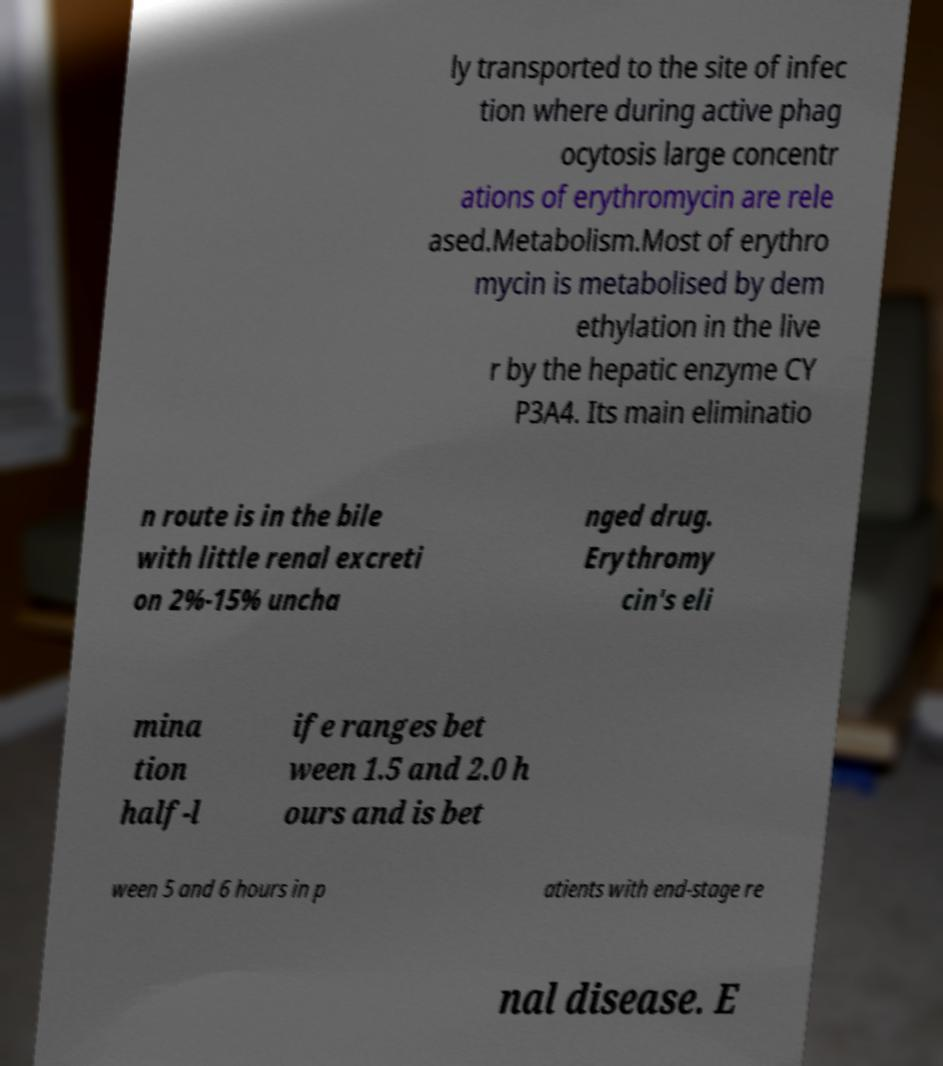Please identify and transcribe the text found in this image. ly transported to the site of infec tion where during active phag ocytosis large concentr ations of erythromycin are rele ased.Metabolism.Most of erythro mycin is metabolised by dem ethylation in the live r by the hepatic enzyme CY P3A4. Its main eliminatio n route is in the bile with little renal excreti on 2%-15% uncha nged drug. Erythromy cin's eli mina tion half-l ife ranges bet ween 1.5 and 2.0 h ours and is bet ween 5 and 6 hours in p atients with end-stage re nal disease. E 